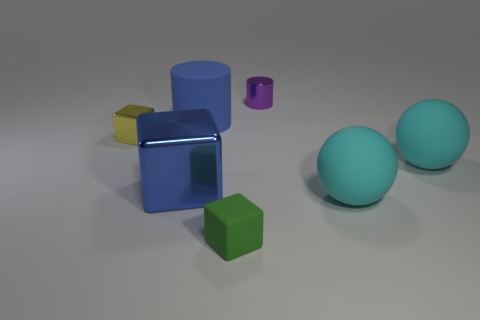Add 3 green matte things. How many objects exist? 10 Subtract all cubes. How many objects are left? 4 Add 3 blue rubber things. How many blue rubber things exist? 4 Subtract 0 gray spheres. How many objects are left? 7 Subtract all small cyan spheres. Subtract all rubber cylinders. How many objects are left? 6 Add 5 big blue metal things. How many big blue metal things are left? 6 